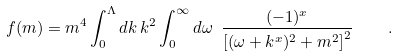<formula> <loc_0><loc_0><loc_500><loc_500>f ( m ) = m ^ { 4 } \int _ { 0 } ^ { \Lambda } d k \, k ^ { 2 } \int _ { 0 } ^ { \infty } d \omega \ \frac { ( - 1 ) ^ { x } } { \left [ ( \omega + k ^ { x } ) ^ { 2 } + m ^ { 2 } \right ] ^ { 2 } } \quad .</formula> 